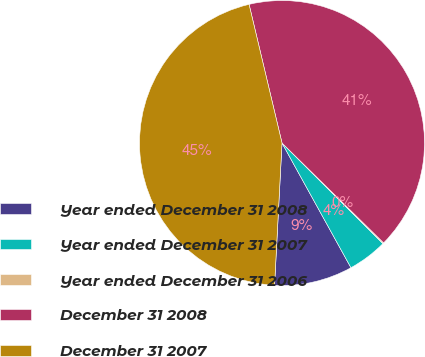Convert chart. <chart><loc_0><loc_0><loc_500><loc_500><pie_chart><fcel>Year ended December 31 2008<fcel>Year ended December 31 2007<fcel>Year ended December 31 2006<fcel>December 31 2008<fcel>December 31 2007<nl><fcel>8.87%<fcel>4.49%<fcel>0.11%<fcel>41.08%<fcel>45.46%<nl></chart> 